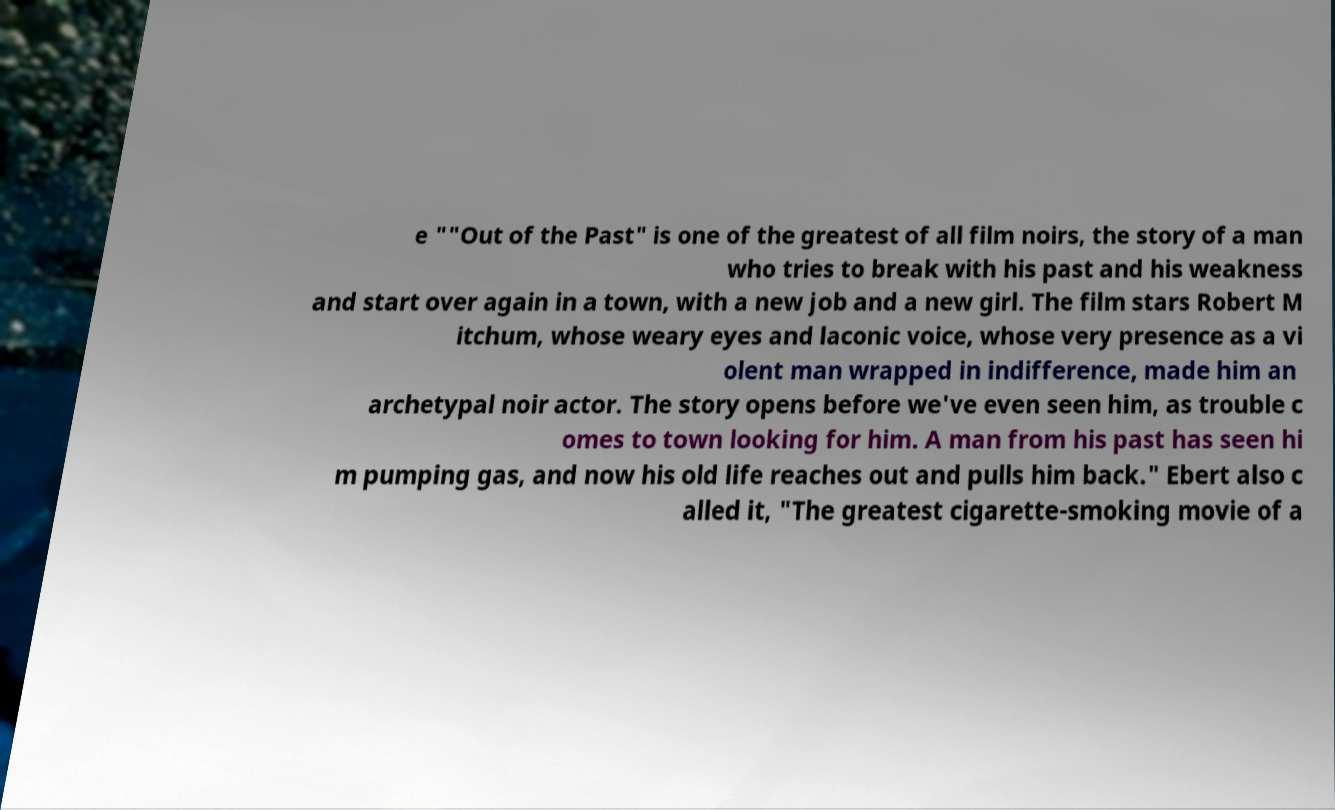Please identify and transcribe the text found in this image. e ""Out of the Past" is one of the greatest of all film noirs, the story of a man who tries to break with his past and his weakness and start over again in a town, with a new job and a new girl. The film stars Robert M itchum, whose weary eyes and laconic voice, whose very presence as a vi olent man wrapped in indifference, made him an archetypal noir actor. The story opens before we've even seen him, as trouble c omes to town looking for him. A man from his past has seen hi m pumping gas, and now his old life reaches out and pulls him back." Ebert also c alled it, "The greatest cigarette-smoking movie of a 